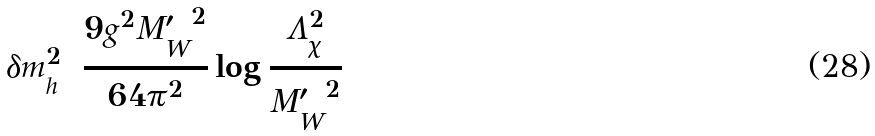Convert formula to latex. <formula><loc_0><loc_0><loc_500><loc_500>\delta m _ { h } ^ { 2 } = \frac { 9 g ^ { 2 } { M ^ { \prime } _ { W } } ^ { 2 } } { 6 4 \pi ^ { 2 } } \log \frac { \Lambda _ { \chi } ^ { 2 } } { { M ^ { \prime } _ { W } } ^ { 2 } }</formula> 